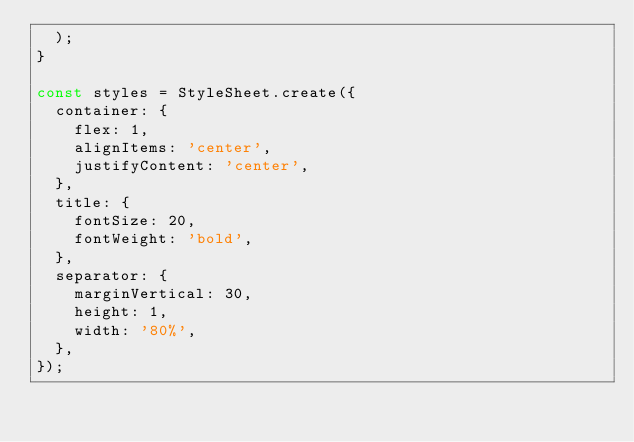Convert code to text. <code><loc_0><loc_0><loc_500><loc_500><_TypeScript_>  );
}

const styles = StyleSheet.create({
  container: {
    flex: 1,
    alignItems: 'center',
    justifyContent: 'center',
  },
  title: {
    fontSize: 20,
    fontWeight: 'bold',
  },
  separator: {
    marginVertical: 30,
    height: 1,
    width: '80%',
  },
});
</code> 